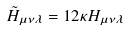Convert formula to latex. <formula><loc_0><loc_0><loc_500><loc_500>\tilde { H } _ { \mu \nu \lambda } = 1 2 \kappa H _ { \mu \nu \lambda }</formula> 